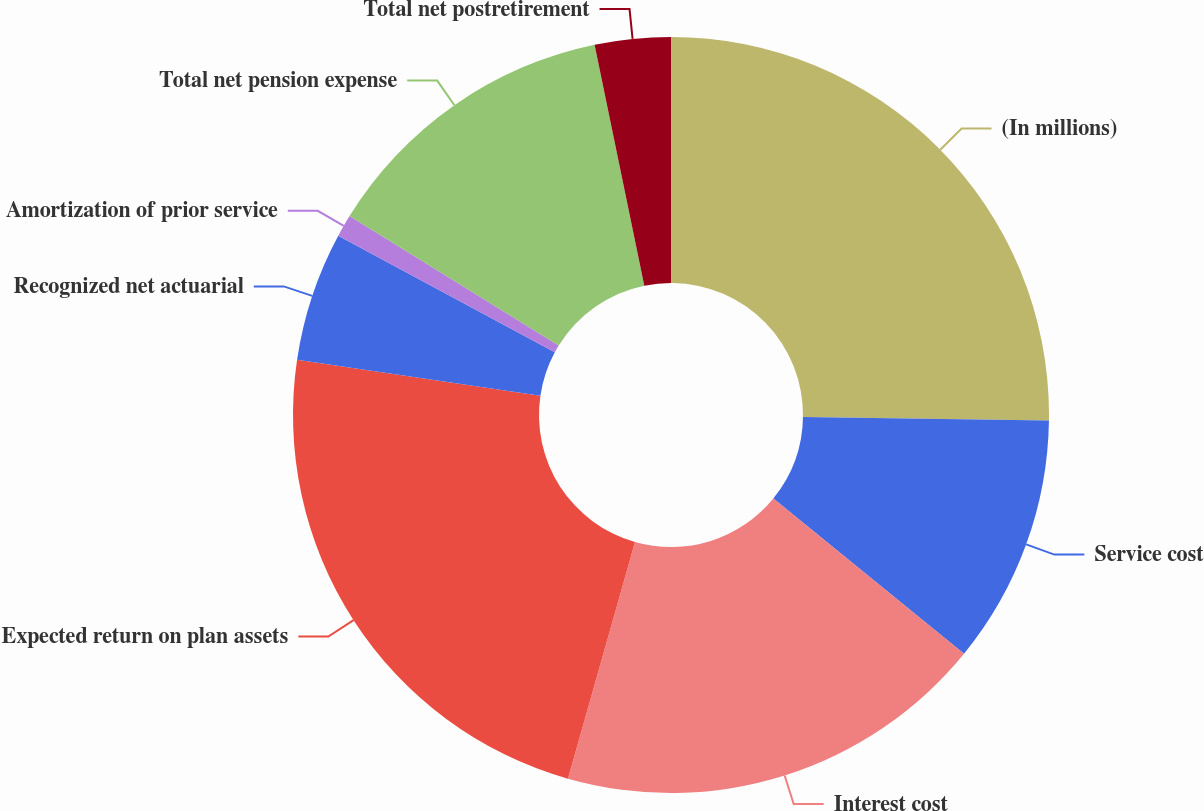Convert chart. <chart><loc_0><loc_0><loc_500><loc_500><pie_chart><fcel>(In millions)<fcel>Service cost<fcel>Interest cost<fcel>Expected return on plan assets<fcel>Recognized net actuarial<fcel>Amortization of prior service<fcel>Total net pension expense<fcel>Total net postretirement<nl><fcel>25.23%<fcel>10.65%<fcel>18.51%<fcel>22.94%<fcel>5.53%<fcel>0.95%<fcel>12.94%<fcel>3.24%<nl></chart> 